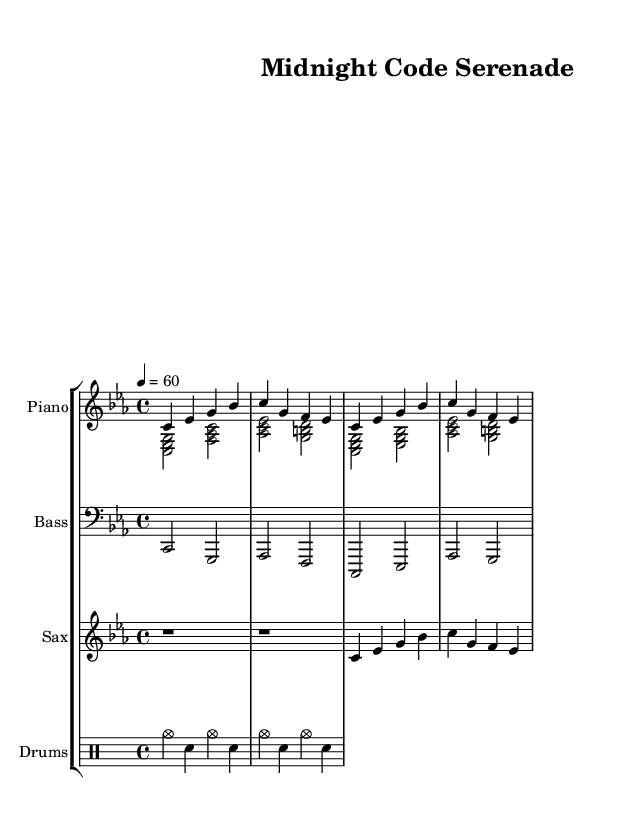What is the key signature of this music? The key signature is C minor, which has three flats (B flat, E flat, A flat).
Answer: C minor What is the time signature of this piece? The time signature is 4/4, indicated at the beginning of the score, meaning there are four beats in each measure.
Answer: 4/4 What is the tempo marking for this composition? The tempo marking indicates a beat of 60 beats per minute, which corresponds to a slow and relaxed feel fitting for late-night sessions.
Answer: 60 How many measures are shown for the piano right hand? There are four measures shown in the piano right hand part, as indicated by the notation.
Answer: Four What is the primary style of this piece? The piece is characterized as cool jazz, which is often defined by its laid-back and smooth sounds, ideal for late-night contexts.
Answer: Cool jazz What instruments are featured in this composition? The composition features piano (both right and left hand), bass, saxophone, and drums, as shown in the score.
Answer: Piano, Bass, Saxophone, Drums What rhythmic style is employed in the drum part? The drum part consists of steady cymbal and snare hits, creating a relaxed and swing-like feel, typical of jazz styles.
Answer: Steady cymbal and snare hits 